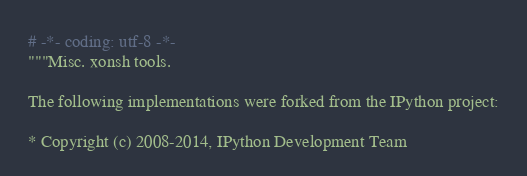<code> <loc_0><loc_0><loc_500><loc_500><_Python_># -*- coding: utf-8 -*-
"""Misc. xonsh tools.

The following implementations were forked from the IPython project:

* Copyright (c) 2008-2014, IPython Development Team</code> 